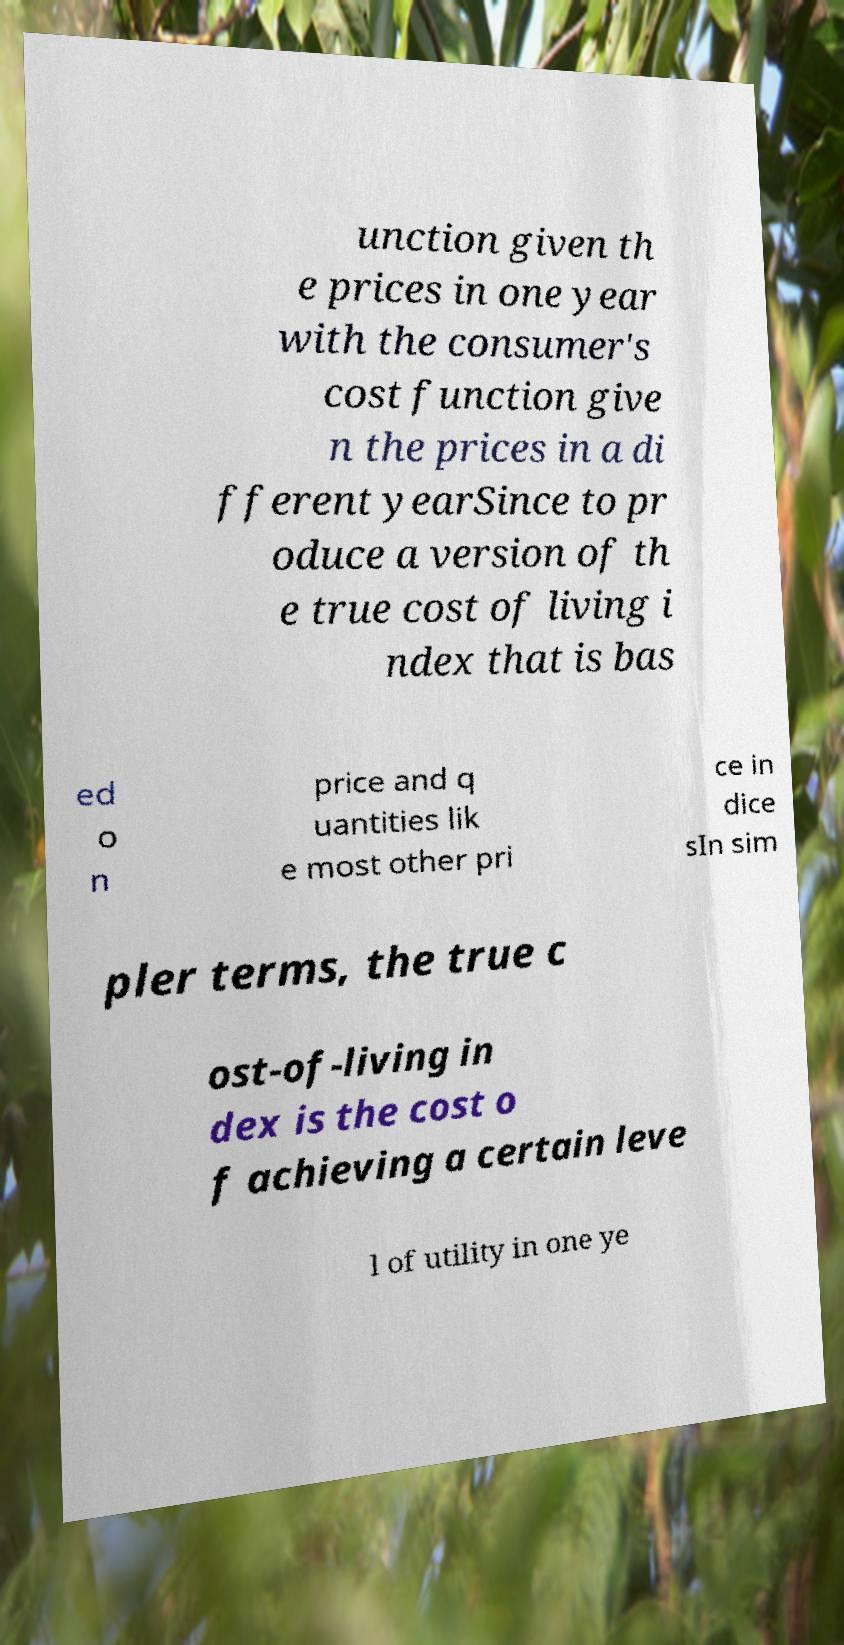What messages or text are displayed in this image? I need them in a readable, typed format. unction given th e prices in one year with the consumer's cost function give n the prices in a di fferent yearSince to pr oduce a version of th e true cost of living i ndex that is bas ed o n price and q uantities lik e most other pri ce in dice sIn sim pler terms, the true c ost-of-living in dex is the cost o f achieving a certain leve l of utility in one ye 